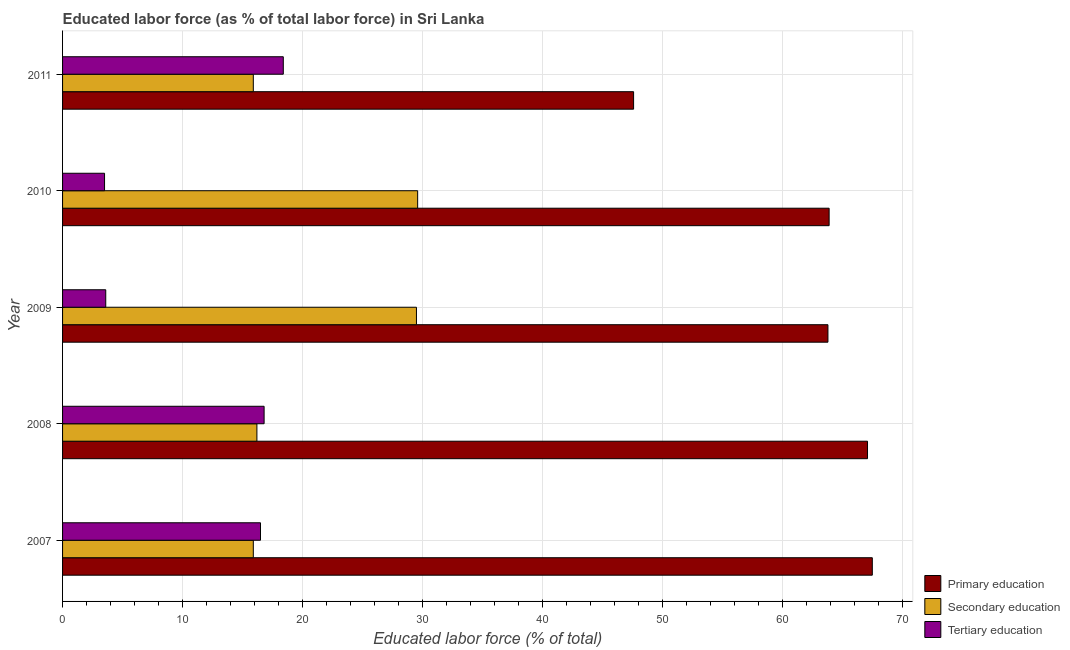How many different coloured bars are there?
Your answer should be very brief. 3. How many groups of bars are there?
Your answer should be very brief. 5. How many bars are there on the 4th tick from the top?
Make the answer very short. 3. What is the label of the 1st group of bars from the top?
Provide a succinct answer. 2011. What is the percentage of labor force who received secondary education in 2010?
Make the answer very short. 29.6. Across all years, what is the maximum percentage of labor force who received tertiary education?
Provide a succinct answer. 18.4. Across all years, what is the minimum percentage of labor force who received secondary education?
Offer a terse response. 15.9. In which year was the percentage of labor force who received primary education maximum?
Give a very brief answer. 2007. In which year was the percentage of labor force who received tertiary education minimum?
Keep it short and to the point. 2010. What is the total percentage of labor force who received secondary education in the graph?
Provide a succinct answer. 107.1. What is the difference between the percentage of labor force who received primary education in 2009 and that in 2010?
Your answer should be compact. -0.1. What is the difference between the percentage of labor force who received secondary education in 2010 and the percentage of labor force who received primary education in 2009?
Offer a very short reply. -34.2. What is the average percentage of labor force who received tertiary education per year?
Offer a terse response. 11.76. In the year 2007, what is the difference between the percentage of labor force who received tertiary education and percentage of labor force who received secondary education?
Offer a very short reply. 0.6. What is the difference between the highest and the second highest percentage of labor force who received tertiary education?
Your answer should be very brief. 1.6. In how many years, is the percentage of labor force who received tertiary education greater than the average percentage of labor force who received tertiary education taken over all years?
Keep it short and to the point. 3. Is the sum of the percentage of labor force who received primary education in 2007 and 2009 greater than the maximum percentage of labor force who received tertiary education across all years?
Your answer should be very brief. Yes. What does the 3rd bar from the top in 2010 represents?
Provide a short and direct response. Primary education. What does the 2nd bar from the bottom in 2011 represents?
Provide a short and direct response. Secondary education. Is it the case that in every year, the sum of the percentage of labor force who received primary education and percentage of labor force who received secondary education is greater than the percentage of labor force who received tertiary education?
Ensure brevity in your answer.  Yes. Are all the bars in the graph horizontal?
Ensure brevity in your answer.  Yes. Does the graph contain grids?
Make the answer very short. Yes. What is the title of the graph?
Make the answer very short. Educated labor force (as % of total labor force) in Sri Lanka. What is the label or title of the X-axis?
Provide a short and direct response. Educated labor force (% of total). What is the label or title of the Y-axis?
Make the answer very short. Year. What is the Educated labor force (% of total) in Primary education in 2007?
Give a very brief answer. 67.5. What is the Educated labor force (% of total) in Secondary education in 2007?
Make the answer very short. 15.9. What is the Educated labor force (% of total) in Primary education in 2008?
Your answer should be compact. 67.1. What is the Educated labor force (% of total) in Secondary education in 2008?
Ensure brevity in your answer.  16.2. What is the Educated labor force (% of total) of Tertiary education in 2008?
Provide a succinct answer. 16.8. What is the Educated labor force (% of total) of Primary education in 2009?
Provide a succinct answer. 63.8. What is the Educated labor force (% of total) of Secondary education in 2009?
Offer a very short reply. 29.5. What is the Educated labor force (% of total) of Tertiary education in 2009?
Give a very brief answer. 3.6. What is the Educated labor force (% of total) of Primary education in 2010?
Make the answer very short. 63.9. What is the Educated labor force (% of total) in Secondary education in 2010?
Your answer should be very brief. 29.6. What is the Educated labor force (% of total) in Tertiary education in 2010?
Ensure brevity in your answer.  3.5. What is the Educated labor force (% of total) in Primary education in 2011?
Keep it short and to the point. 47.6. What is the Educated labor force (% of total) in Secondary education in 2011?
Offer a terse response. 15.9. What is the Educated labor force (% of total) in Tertiary education in 2011?
Provide a short and direct response. 18.4. Across all years, what is the maximum Educated labor force (% of total) of Primary education?
Give a very brief answer. 67.5. Across all years, what is the maximum Educated labor force (% of total) of Secondary education?
Make the answer very short. 29.6. Across all years, what is the maximum Educated labor force (% of total) of Tertiary education?
Your answer should be very brief. 18.4. Across all years, what is the minimum Educated labor force (% of total) of Primary education?
Provide a succinct answer. 47.6. Across all years, what is the minimum Educated labor force (% of total) of Secondary education?
Provide a short and direct response. 15.9. Across all years, what is the minimum Educated labor force (% of total) of Tertiary education?
Ensure brevity in your answer.  3.5. What is the total Educated labor force (% of total) of Primary education in the graph?
Provide a short and direct response. 309.9. What is the total Educated labor force (% of total) of Secondary education in the graph?
Your answer should be very brief. 107.1. What is the total Educated labor force (% of total) of Tertiary education in the graph?
Ensure brevity in your answer.  58.8. What is the difference between the Educated labor force (% of total) in Primary education in 2007 and that in 2008?
Make the answer very short. 0.4. What is the difference between the Educated labor force (% of total) of Secondary education in 2007 and that in 2008?
Ensure brevity in your answer.  -0.3. What is the difference between the Educated labor force (% of total) of Primary education in 2007 and that in 2009?
Offer a very short reply. 3.7. What is the difference between the Educated labor force (% of total) of Secondary education in 2007 and that in 2009?
Your answer should be compact. -13.6. What is the difference between the Educated labor force (% of total) in Tertiary education in 2007 and that in 2009?
Give a very brief answer. 12.9. What is the difference between the Educated labor force (% of total) of Primary education in 2007 and that in 2010?
Give a very brief answer. 3.6. What is the difference between the Educated labor force (% of total) of Secondary education in 2007 and that in 2010?
Offer a very short reply. -13.7. What is the difference between the Educated labor force (% of total) of Primary education in 2007 and that in 2011?
Offer a very short reply. 19.9. What is the difference between the Educated labor force (% of total) in Secondary education in 2007 and that in 2011?
Your response must be concise. 0. What is the difference between the Educated labor force (% of total) in Primary education in 2008 and that in 2009?
Provide a short and direct response. 3.3. What is the difference between the Educated labor force (% of total) of Secondary education in 2008 and that in 2009?
Provide a succinct answer. -13.3. What is the difference between the Educated labor force (% of total) in Tertiary education in 2008 and that in 2009?
Your response must be concise. 13.2. What is the difference between the Educated labor force (% of total) of Primary education in 2008 and that in 2010?
Provide a short and direct response. 3.2. What is the difference between the Educated labor force (% of total) in Secondary education in 2008 and that in 2010?
Ensure brevity in your answer.  -13.4. What is the difference between the Educated labor force (% of total) of Tertiary education in 2008 and that in 2010?
Offer a very short reply. 13.3. What is the difference between the Educated labor force (% of total) of Primary education in 2008 and that in 2011?
Provide a succinct answer. 19.5. What is the difference between the Educated labor force (% of total) in Secondary education in 2008 and that in 2011?
Your response must be concise. 0.3. What is the difference between the Educated labor force (% of total) in Tertiary education in 2008 and that in 2011?
Make the answer very short. -1.6. What is the difference between the Educated labor force (% of total) in Primary education in 2009 and that in 2010?
Your response must be concise. -0.1. What is the difference between the Educated labor force (% of total) in Tertiary education in 2009 and that in 2010?
Ensure brevity in your answer.  0.1. What is the difference between the Educated labor force (% of total) in Tertiary education in 2009 and that in 2011?
Give a very brief answer. -14.8. What is the difference between the Educated labor force (% of total) of Tertiary education in 2010 and that in 2011?
Offer a terse response. -14.9. What is the difference between the Educated labor force (% of total) in Primary education in 2007 and the Educated labor force (% of total) in Secondary education in 2008?
Offer a terse response. 51.3. What is the difference between the Educated labor force (% of total) of Primary education in 2007 and the Educated labor force (% of total) of Tertiary education in 2008?
Your response must be concise. 50.7. What is the difference between the Educated labor force (% of total) of Primary education in 2007 and the Educated labor force (% of total) of Tertiary education in 2009?
Provide a short and direct response. 63.9. What is the difference between the Educated labor force (% of total) in Secondary education in 2007 and the Educated labor force (% of total) in Tertiary education in 2009?
Give a very brief answer. 12.3. What is the difference between the Educated labor force (% of total) in Primary education in 2007 and the Educated labor force (% of total) in Secondary education in 2010?
Give a very brief answer. 37.9. What is the difference between the Educated labor force (% of total) in Primary education in 2007 and the Educated labor force (% of total) in Tertiary education in 2010?
Your response must be concise. 64. What is the difference between the Educated labor force (% of total) of Primary education in 2007 and the Educated labor force (% of total) of Secondary education in 2011?
Provide a succinct answer. 51.6. What is the difference between the Educated labor force (% of total) in Primary education in 2007 and the Educated labor force (% of total) in Tertiary education in 2011?
Your response must be concise. 49.1. What is the difference between the Educated labor force (% of total) of Secondary education in 2007 and the Educated labor force (% of total) of Tertiary education in 2011?
Keep it short and to the point. -2.5. What is the difference between the Educated labor force (% of total) in Primary education in 2008 and the Educated labor force (% of total) in Secondary education in 2009?
Give a very brief answer. 37.6. What is the difference between the Educated labor force (% of total) of Primary education in 2008 and the Educated labor force (% of total) of Tertiary education in 2009?
Offer a very short reply. 63.5. What is the difference between the Educated labor force (% of total) in Secondary education in 2008 and the Educated labor force (% of total) in Tertiary education in 2009?
Your response must be concise. 12.6. What is the difference between the Educated labor force (% of total) in Primary education in 2008 and the Educated labor force (% of total) in Secondary education in 2010?
Provide a succinct answer. 37.5. What is the difference between the Educated labor force (% of total) of Primary education in 2008 and the Educated labor force (% of total) of Tertiary education in 2010?
Your response must be concise. 63.6. What is the difference between the Educated labor force (% of total) in Secondary education in 2008 and the Educated labor force (% of total) in Tertiary education in 2010?
Provide a succinct answer. 12.7. What is the difference between the Educated labor force (% of total) of Primary education in 2008 and the Educated labor force (% of total) of Secondary education in 2011?
Offer a very short reply. 51.2. What is the difference between the Educated labor force (% of total) in Primary education in 2008 and the Educated labor force (% of total) in Tertiary education in 2011?
Make the answer very short. 48.7. What is the difference between the Educated labor force (% of total) in Primary education in 2009 and the Educated labor force (% of total) in Secondary education in 2010?
Provide a succinct answer. 34.2. What is the difference between the Educated labor force (% of total) of Primary education in 2009 and the Educated labor force (% of total) of Tertiary education in 2010?
Provide a short and direct response. 60.3. What is the difference between the Educated labor force (% of total) of Secondary education in 2009 and the Educated labor force (% of total) of Tertiary education in 2010?
Offer a very short reply. 26. What is the difference between the Educated labor force (% of total) in Primary education in 2009 and the Educated labor force (% of total) in Secondary education in 2011?
Your answer should be very brief. 47.9. What is the difference between the Educated labor force (% of total) in Primary education in 2009 and the Educated labor force (% of total) in Tertiary education in 2011?
Make the answer very short. 45.4. What is the difference between the Educated labor force (% of total) in Secondary education in 2009 and the Educated labor force (% of total) in Tertiary education in 2011?
Provide a succinct answer. 11.1. What is the difference between the Educated labor force (% of total) of Primary education in 2010 and the Educated labor force (% of total) of Secondary education in 2011?
Provide a short and direct response. 48. What is the difference between the Educated labor force (% of total) of Primary education in 2010 and the Educated labor force (% of total) of Tertiary education in 2011?
Make the answer very short. 45.5. What is the difference between the Educated labor force (% of total) in Secondary education in 2010 and the Educated labor force (% of total) in Tertiary education in 2011?
Give a very brief answer. 11.2. What is the average Educated labor force (% of total) in Primary education per year?
Make the answer very short. 61.98. What is the average Educated labor force (% of total) in Secondary education per year?
Your answer should be very brief. 21.42. What is the average Educated labor force (% of total) of Tertiary education per year?
Your answer should be very brief. 11.76. In the year 2007, what is the difference between the Educated labor force (% of total) of Primary education and Educated labor force (% of total) of Secondary education?
Provide a short and direct response. 51.6. In the year 2008, what is the difference between the Educated labor force (% of total) in Primary education and Educated labor force (% of total) in Secondary education?
Make the answer very short. 50.9. In the year 2008, what is the difference between the Educated labor force (% of total) in Primary education and Educated labor force (% of total) in Tertiary education?
Keep it short and to the point. 50.3. In the year 2008, what is the difference between the Educated labor force (% of total) in Secondary education and Educated labor force (% of total) in Tertiary education?
Your response must be concise. -0.6. In the year 2009, what is the difference between the Educated labor force (% of total) of Primary education and Educated labor force (% of total) of Secondary education?
Your answer should be very brief. 34.3. In the year 2009, what is the difference between the Educated labor force (% of total) of Primary education and Educated labor force (% of total) of Tertiary education?
Your answer should be compact. 60.2. In the year 2009, what is the difference between the Educated labor force (% of total) in Secondary education and Educated labor force (% of total) in Tertiary education?
Your response must be concise. 25.9. In the year 2010, what is the difference between the Educated labor force (% of total) in Primary education and Educated labor force (% of total) in Secondary education?
Your answer should be compact. 34.3. In the year 2010, what is the difference between the Educated labor force (% of total) of Primary education and Educated labor force (% of total) of Tertiary education?
Provide a succinct answer. 60.4. In the year 2010, what is the difference between the Educated labor force (% of total) in Secondary education and Educated labor force (% of total) in Tertiary education?
Your answer should be compact. 26.1. In the year 2011, what is the difference between the Educated labor force (% of total) of Primary education and Educated labor force (% of total) of Secondary education?
Offer a terse response. 31.7. In the year 2011, what is the difference between the Educated labor force (% of total) of Primary education and Educated labor force (% of total) of Tertiary education?
Keep it short and to the point. 29.2. What is the ratio of the Educated labor force (% of total) of Secondary education in 2007 to that in 2008?
Provide a succinct answer. 0.98. What is the ratio of the Educated labor force (% of total) in Tertiary education in 2007 to that in 2008?
Ensure brevity in your answer.  0.98. What is the ratio of the Educated labor force (% of total) of Primary education in 2007 to that in 2009?
Make the answer very short. 1.06. What is the ratio of the Educated labor force (% of total) in Secondary education in 2007 to that in 2009?
Provide a short and direct response. 0.54. What is the ratio of the Educated labor force (% of total) in Tertiary education in 2007 to that in 2009?
Provide a short and direct response. 4.58. What is the ratio of the Educated labor force (% of total) in Primary education in 2007 to that in 2010?
Provide a short and direct response. 1.06. What is the ratio of the Educated labor force (% of total) in Secondary education in 2007 to that in 2010?
Offer a very short reply. 0.54. What is the ratio of the Educated labor force (% of total) in Tertiary education in 2007 to that in 2010?
Your answer should be compact. 4.71. What is the ratio of the Educated labor force (% of total) of Primary education in 2007 to that in 2011?
Make the answer very short. 1.42. What is the ratio of the Educated labor force (% of total) of Secondary education in 2007 to that in 2011?
Provide a short and direct response. 1. What is the ratio of the Educated labor force (% of total) in Tertiary education in 2007 to that in 2011?
Provide a short and direct response. 0.9. What is the ratio of the Educated labor force (% of total) in Primary education in 2008 to that in 2009?
Ensure brevity in your answer.  1.05. What is the ratio of the Educated labor force (% of total) of Secondary education in 2008 to that in 2009?
Keep it short and to the point. 0.55. What is the ratio of the Educated labor force (% of total) of Tertiary education in 2008 to that in 2009?
Offer a very short reply. 4.67. What is the ratio of the Educated labor force (% of total) of Primary education in 2008 to that in 2010?
Make the answer very short. 1.05. What is the ratio of the Educated labor force (% of total) in Secondary education in 2008 to that in 2010?
Make the answer very short. 0.55. What is the ratio of the Educated labor force (% of total) of Tertiary education in 2008 to that in 2010?
Your answer should be very brief. 4.8. What is the ratio of the Educated labor force (% of total) of Primary education in 2008 to that in 2011?
Give a very brief answer. 1.41. What is the ratio of the Educated labor force (% of total) in Secondary education in 2008 to that in 2011?
Keep it short and to the point. 1.02. What is the ratio of the Educated labor force (% of total) of Tertiary education in 2009 to that in 2010?
Your response must be concise. 1.03. What is the ratio of the Educated labor force (% of total) in Primary education in 2009 to that in 2011?
Ensure brevity in your answer.  1.34. What is the ratio of the Educated labor force (% of total) in Secondary education in 2009 to that in 2011?
Your response must be concise. 1.86. What is the ratio of the Educated labor force (% of total) in Tertiary education in 2009 to that in 2011?
Make the answer very short. 0.2. What is the ratio of the Educated labor force (% of total) in Primary education in 2010 to that in 2011?
Make the answer very short. 1.34. What is the ratio of the Educated labor force (% of total) in Secondary education in 2010 to that in 2011?
Make the answer very short. 1.86. What is the ratio of the Educated labor force (% of total) in Tertiary education in 2010 to that in 2011?
Give a very brief answer. 0.19. What is the difference between the highest and the second highest Educated labor force (% of total) in Tertiary education?
Offer a terse response. 1.6. 